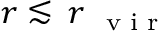<formula> <loc_0><loc_0><loc_500><loc_500>r \lesssim \, r _ { v i r }</formula> 